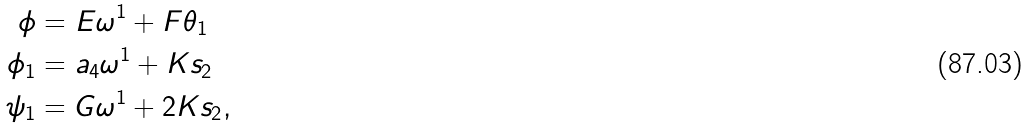Convert formula to latex. <formula><loc_0><loc_0><loc_500><loc_500>\phi & = E \omega ^ { 1 } + F \theta _ { 1 } \\ \phi _ { 1 } & = a _ { 4 } \omega ^ { 1 } + K s _ { 2 } \\ \psi _ { 1 } & = G \omega ^ { 1 } + 2 K s _ { 2 } ,</formula> 